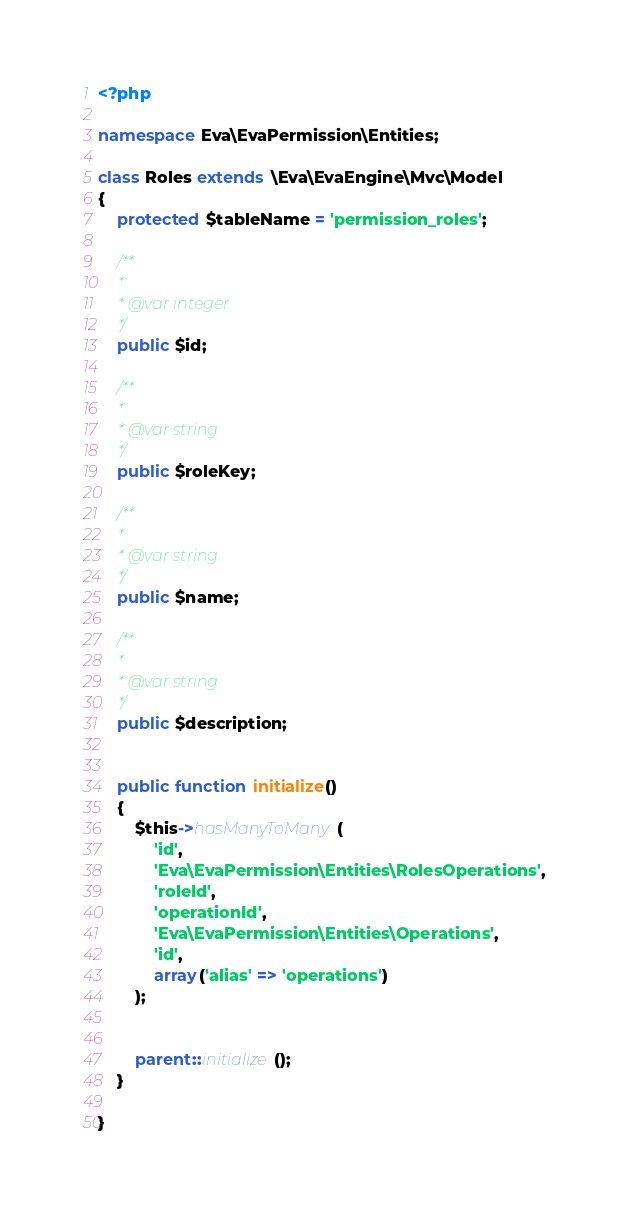Convert code to text. <code><loc_0><loc_0><loc_500><loc_500><_PHP_><?php

namespace Eva\EvaPermission\Entities;

class Roles extends \Eva\EvaEngine\Mvc\Model
{
    protected $tableName = 'permission_roles';

    /**
     *
     * @var integer
     */
    public $id;

    /**
     *
     * @var string
     */
    public $roleKey;

    /**
     *
     * @var string
     */
    public $name;

    /**
     *
     * @var string
     */
    public $description;


    public function initialize()
    {
        $this->hasManyToMany(
            'id',
            'Eva\EvaPermission\Entities\RolesOperations',
            'roleId',
            'operationId',
            'Eva\EvaPermission\Entities\Operations',
            'id',
            array('alias' => 'operations')
        );


        parent::initialize();
    }

}
</code> 